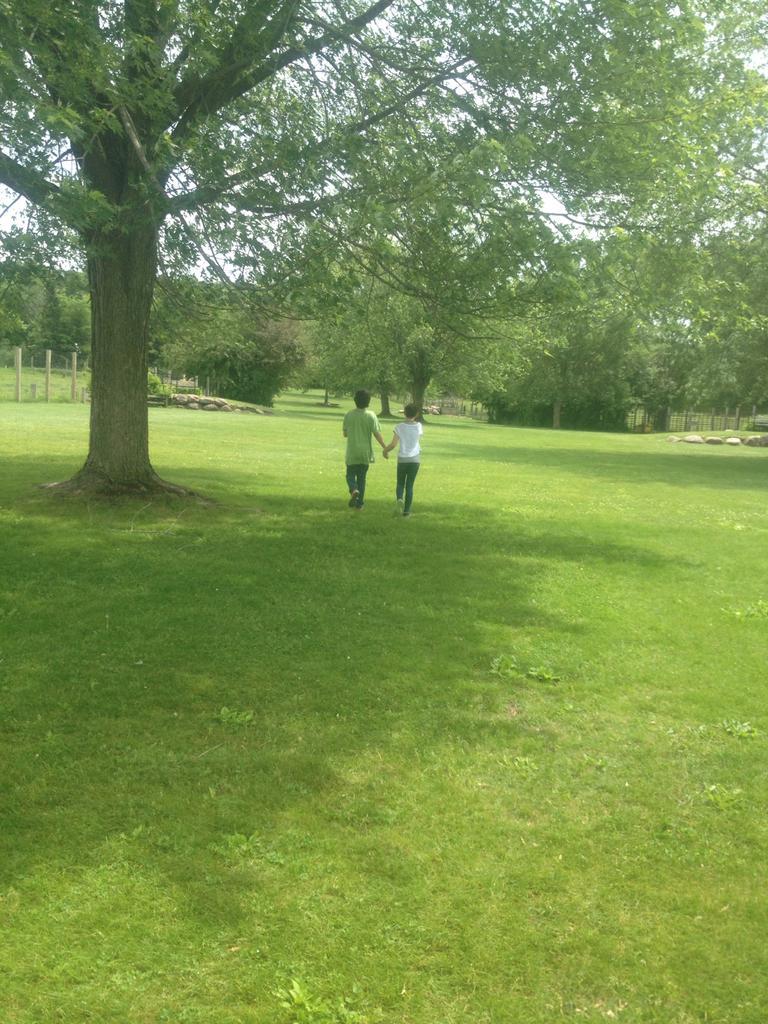Please provide a concise description of this image. In the center of the image, we can see people walking on the ground and in the background, there are trees, stones and a fence. 